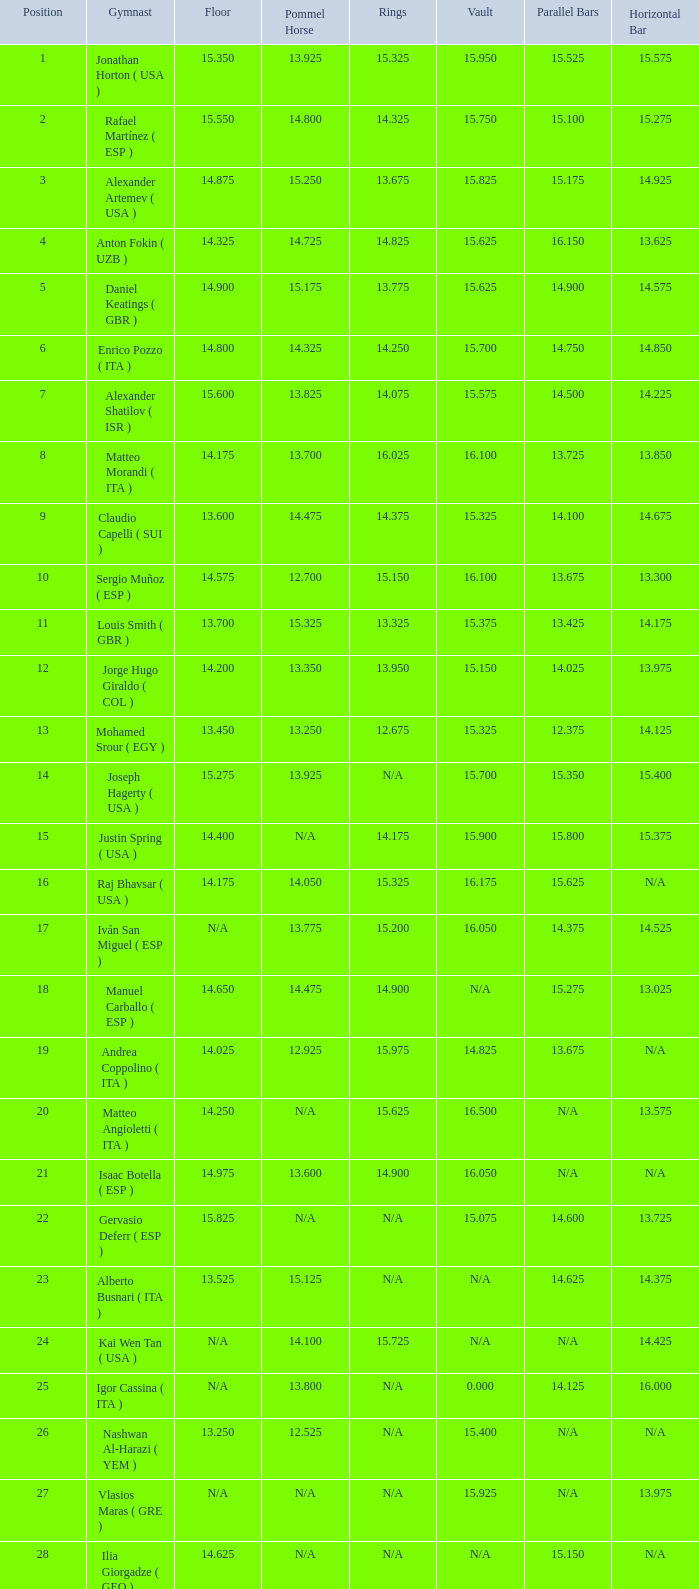Can you give me this table as a dict? {'header': ['Position', 'Gymnast', 'Floor', 'Pommel Horse', 'Rings', 'Vault', 'Parallel Bars', 'Horizontal Bar'], 'rows': [['1', 'Jonathan Horton ( USA )', '15.350', '13.925', '15.325', '15.950', '15.525', '15.575'], ['2', 'Rafael Martínez ( ESP )', '15.550', '14.800', '14.325', '15.750', '15.100', '15.275'], ['3', 'Alexander Artemev ( USA )', '14.875', '15.250', '13.675', '15.825', '15.175', '14.925'], ['4', 'Anton Fokin ( UZB )', '14.325', '14.725', '14.825', '15.625', '16.150', '13.625'], ['5', 'Daniel Keatings ( GBR )', '14.900', '15.175', '13.775', '15.625', '14.900', '14.575'], ['6', 'Enrico Pozzo ( ITA )', '14.800', '14.325', '14.250', '15.700', '14.750', '14.850'], ['7', 'Alexander Shatilov ( ISR )', '15.600', '13.825', '14.075', '15.575', '14.500', '14.225'], ['8', 'Matteo Morandi ( ITA )', '14.175', '13.700', '16.025', '16.100', '13.725', '13.850'], ['9', 'Claudio Capelli ( SUI )', '13.600', '14.475', '14.375', '15.325', '14.100', '14.675'], ['10', 'Sergio Muñoz ( ESP )', '14.575', '12.700', '15.150', '16.100', '13.675', '13.300'], ['11', 'Louis Smith ( GBR )', '13.700', '15.325', '13.325', '15.375', '13.425', '14.175'], ['12', 'Jorge Hugo Giraldo ( COL )', '14.200', '13.350', '13.950', '15.150', '14.025', '13.975'], ['13', 'Mohamed Srour ( EGY )', '13.450', '13.250', '12.675', '15.325', '12.375', '14.125'], ['14', 'Joseph Hagerty ( USA )', '15.275', '13.925', 'N/A', '15.700', '15.350', '15.400'], ['15', 'Justin Spring ( USA )', '14.400', 'N/A', '14.175', '15.900', '15.800', '15.375'], ['16', 'Raj Bhavsar ( USA )', '14.175', '14.050', '15.325', '16.175', '15.625', 'N/A'], ['17', 'Iván San Miguel ( ESP )', 'N/A', '13.775', '15.200', '16.050', '14.375', '14.525'], ['18', 'Manuel Carballo ( ESP )', '14.650', '14.475', '14.900', 'N/A', '15.275', '13.025'], ['19', 'Andrea Coppolino ( ITA )', '14.025', '12.925', '15.975', '14.825', '13.675', 'N/A'], ['20', 'Matteo Angioletti ( ITA )', '14.250', 'N/A', '15.625', '16.500', 'N/A', '13.575'], ['21', 'Isaac Botella ( ESP )', '14.975', '13.600', '14.900', '16.050', 'N/A', 'N/A'], ['22', 'Gervasio Deferr ( ESP )', '15.825', 'N/A', 'N/A', '15.075', '14.600', '13.725'], ['23', 'Alberto Busnari ( ITA )', '13.525', '15.125', 'N/A', 'N/A', '14.625', '14.375'], ['24', 'Kai Wen Tan ( USA )', 'N/A', '14.100', '15.725', 'N/A', 'N/A', '14.425'], ['25', 'Igor Cassina ( ITA )', 'N/A', '13.800', 'N/A', '0.000', '14.125', '16.000'], ['26', 'Nashwan Al-Harazi ( YEM )', '13.250', '12.525', 'N/A', '15.400', 'N/A', 'N/A'], ['27', 'Vlasios Maras ( GRE )', 'N/A', 'N/A', 'N/A', '15.925', 'N/A', '13.975'], ['28', 'Ilia Giorgadze ( GEO )', '14.625', 'N/A', 'N/A', 'N/A', '15.150', 'N/A'], ['29', 'Christoph Schärer ( SUI )', 'N/A', '13.150', 'N/A', 'N/A', 'N/A', '15.350'], ['30', 'Leszek Blanik ( POL )', 'N/A', 'N/A', 'N/A', '16.700', 'N/A', 'N/A']]} If the parallel bars is 16.150, who is the gymnast? Anton Fokin ( UZB ). 